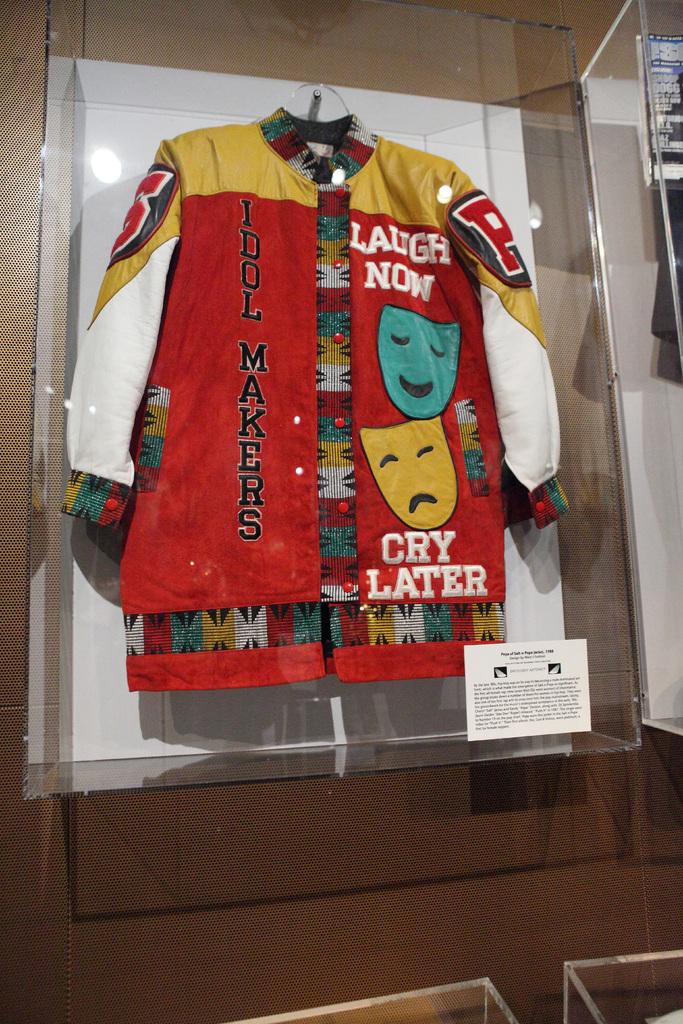What does the jacket say to do now, and then later?
Your response must be concise. Laugh now cry later. Whats written vertical on the left side of the coat?
Keep it short and to the point. Idol makers. 